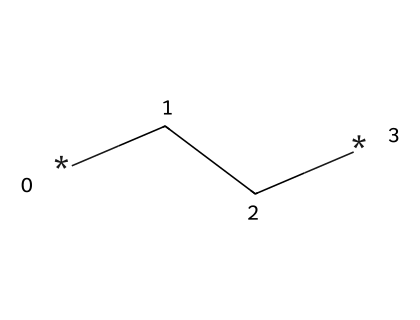How many carbon atoms are present in polyethylene? The structure of polyethylene, represented by the SMILES *CC*, shows that it consists of two carbon atoms. The notation indicates a simple chain of carbon atoms.
Answer: two What type of polymer is represented by the SMILES *CC*? The SMILES *CC* denotes a linear chain structure indicating that this compound is an aliphatic polymer formed only from carbon and hydrogen. Polyethylene falls into the category of addition polymers.
Answer: addition polymer How many hydrogen atoms are in polyethylene represented by *CC*? Each carbon atom in the chain of polyethylene is typically bonded to enough hydrogen atoms to fulfill the tetravalency of carbon, leading to a resulting formula of CnH2n+2. For the two carbon atoms, there are four hydrogens.
Answer: four Is the structure represented by *CC* rigid or flexible? The nature of polyethylene, having predominantly single bonds between carbon atoms, allows for the molecule to be flexible rather than rigid, as there is rotational freedom about the carbon-carbon single bonds.
Answer: flexible What characteristic of polyethylene contributes to its common usage in insulation for computer hardware? Polyethylene's non-polar nature and low dielectric constant make it an excellent insulator, preventing electrical conductivity. This physical property results from the arrangement of the carbon and hydrogen atoms in its structure.
Answer: non-polar 